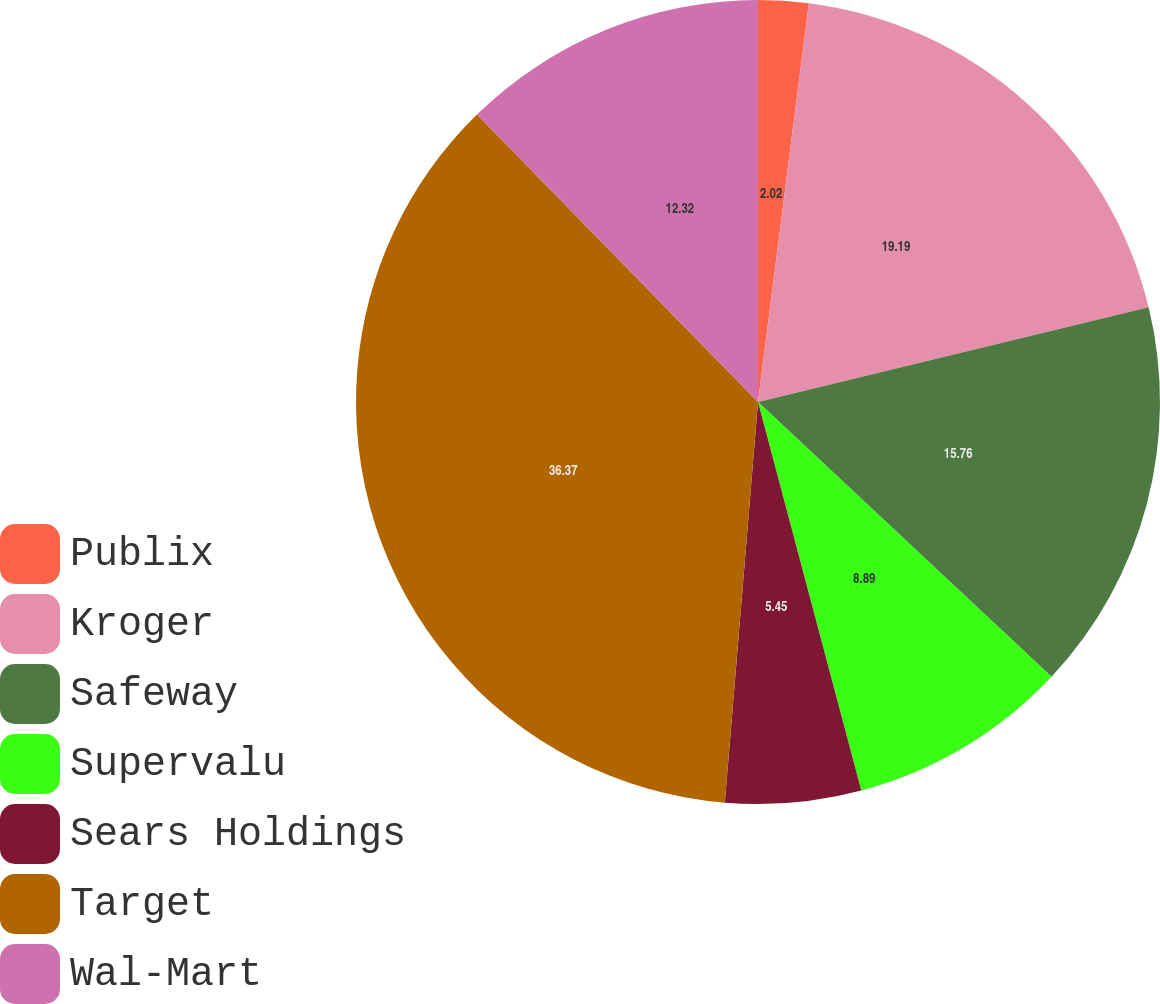Convert chart. <chart><loc_0><loc_0><loc_500><loc_500><pie_chart><fcel>Publix<fcel>Kroger<fcel>Safeway<fcel>Supervalu<fcel>Sears Holdings<fcel>Target<fcel>Wal-Mart<nl><fcel>2.02%<fcel>19.19%<fcel>15.76%<fcel>8.89%<fcel>5.45%<fcel>36.36%<fcel>12.32%<nl></chart> 